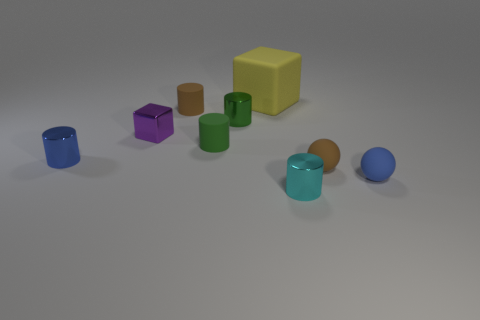Subtract all tiny green metallic cylinders. How many cylinders are left? 4 Add 1 tiny brown matte spheres. How many objects exist? 10 Subtract all yellow spheres. How many green cylinders are left? 2 Subtract all brown cylinders. How many cylinders are left? 4 Subtract all cylinders. How many objects are left? 4 Subtract 1 purple cubes. How many objects are left? 8 Subtract all green cubes. Subtract all cyan cylinders. How many cubes are left? 2 Subtract all brown rubber spheres. Subtract all brown rubber cylinders. How many objects are left? 7 Add 3 brown matte spheres. How many brown matte spheres are left? 4 Add 8 cyan cylinders. How many cyan cylinders exist? 9 